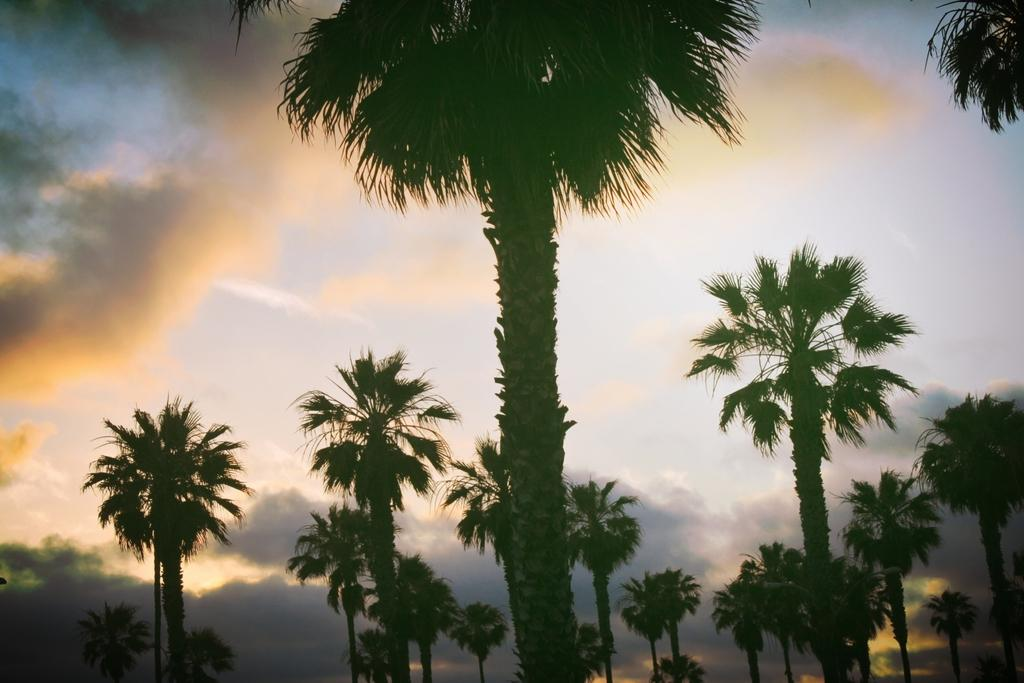What type of vegetation can be seen in the image? There is a group of trees in the image. What else is visible in the image besides the trees? The sky is visible in the image. How would you describe the sky in the image? The sky appears to be cloudy. What type of coach can be seen driving down the alley in the image? There is no coach or alley present in the image; it features a group of trees and a cloudy sky. 